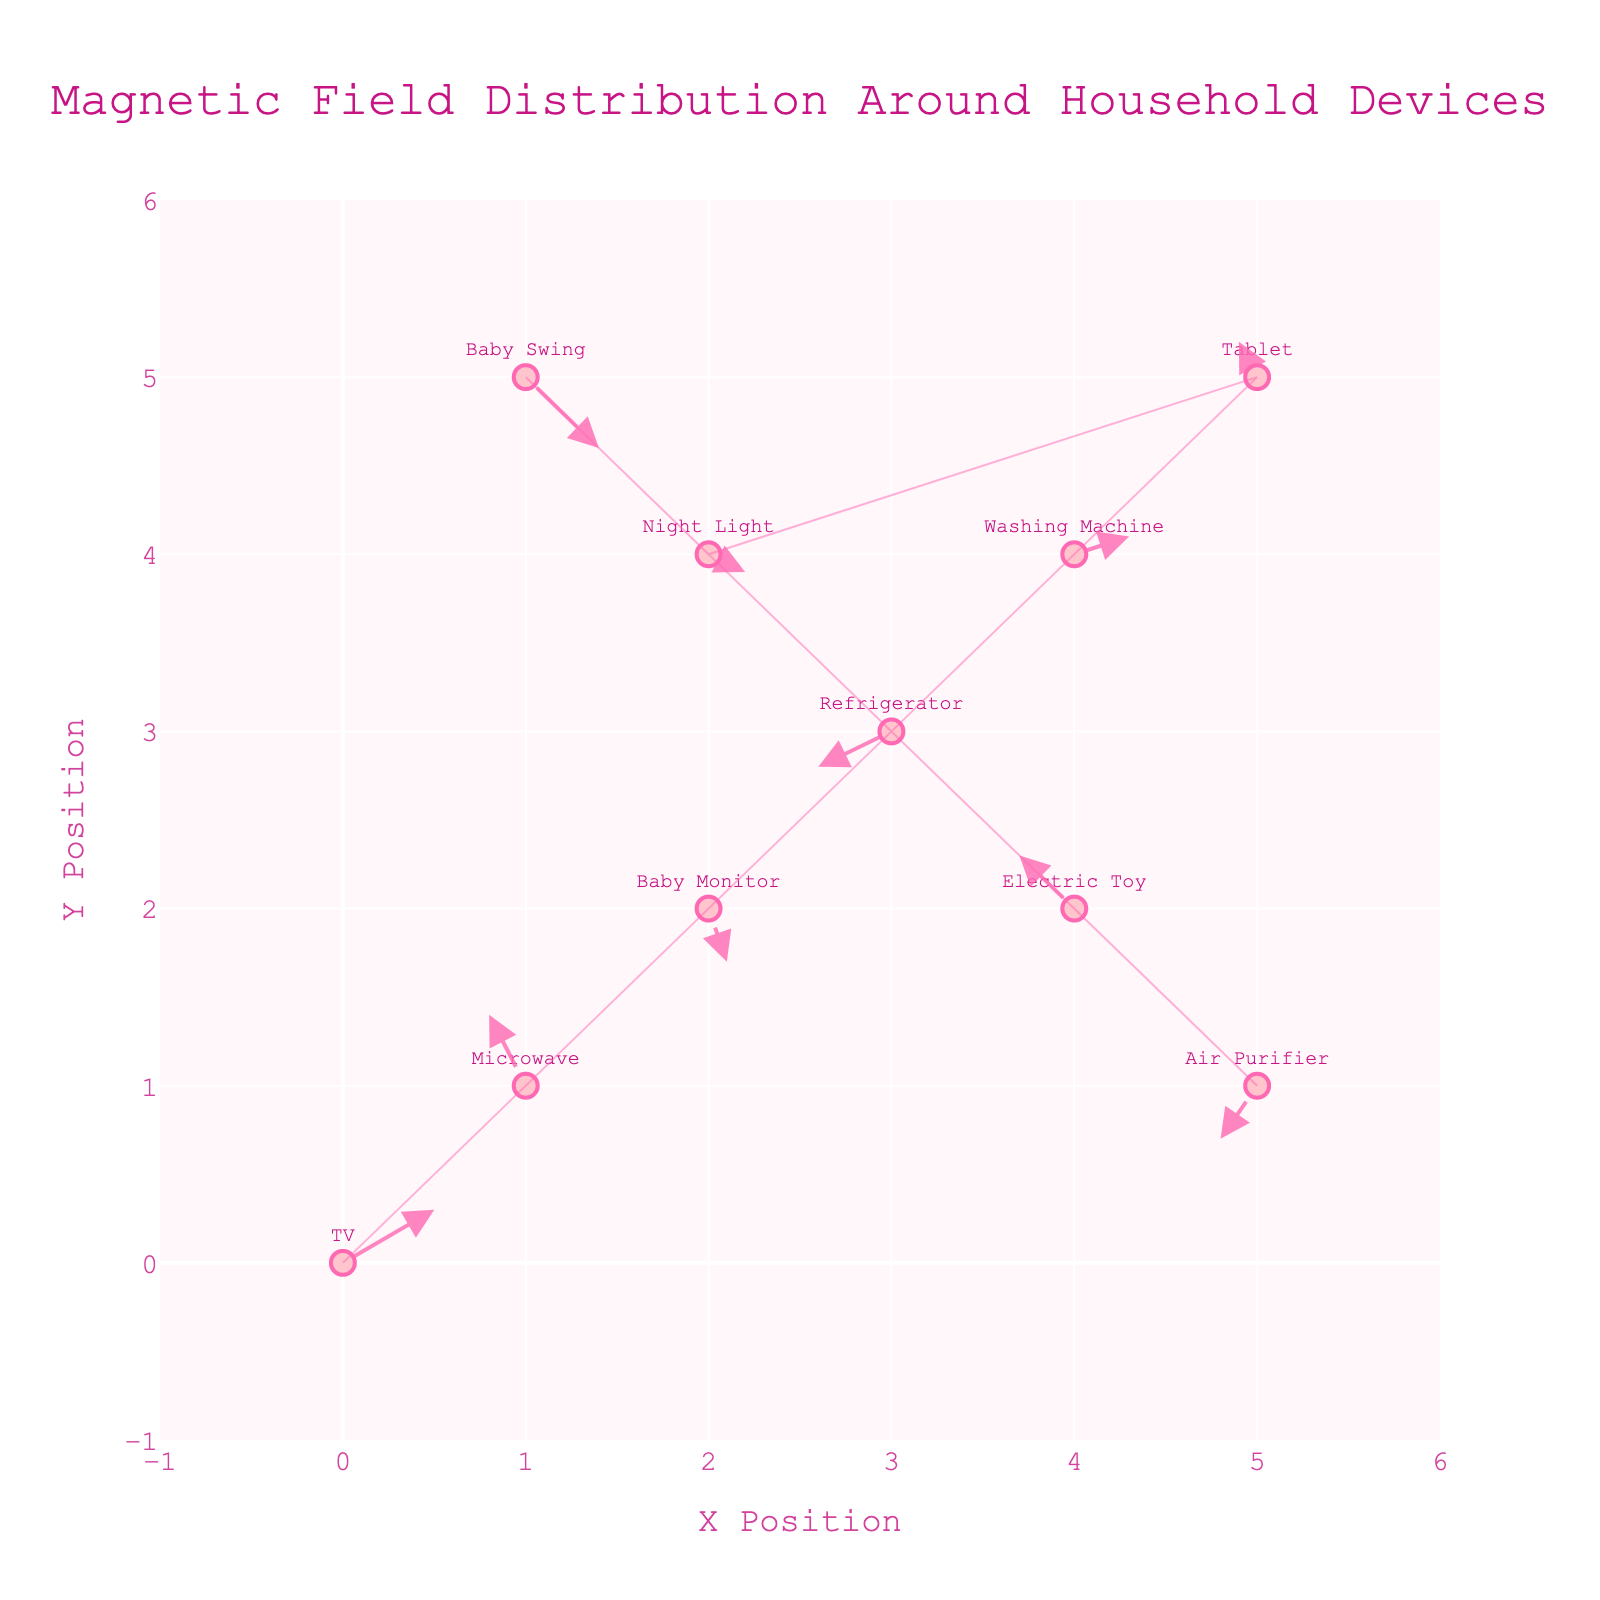What is the title of the plot? The title of the plot is usually located at the top center of the figure. In this case, according to our description, it says "Magnetic Field Distribution Around Household Devices."
Answer: Magnetic Field Distribution Around Household Devices How many electronic devices are shown in the plot? Each device is marked by a label with its name. By counting the unique labels, we find that there are 10 devices.
Answer: 10 Which device is located at the position (5, 5)? To find this, locate the coordinates (5, 5) on the plot and check the label of the device positioned there. It is marked as "Tablet."
Answer: Tablet Which device has the strongest magnetic field in the negative X direction? To identify this, look at the vector lengths and directions pointing leftward (negative X direction). The Refrigerator at (3, 3) has a U value of -0.4, which is the strongest in the negative X direction.
Answer: Refrigerator What is the color of the arrows in the plot? The arrows are colored 'rgba(255, 105, 180, 0.8)', which translates to a shade of pink.
Answer: Pink Which device exerts a magnetic field vector of (0.2, -0.1)? Match the given vector (0.2, -0.1) with the device vectors shown in the plot. The device at (2, 4) labeled "Night Light" has this vector.
Answer: Night Light Compare the magnetic field directions of the TV and the Air Purifier. Are they in the same, opposite, or different directions? The TV at (0, 0) has a vector (0.5, 0.3) directing generally right and upwards, whereas the Air Purifier at (5, 1) has a vector (-0.2, -0.3) directing left and downwards. Their directions are opposite.
Answer: Opposite What is the average magnitude of the magnetic field vectors for the devices located at y=4? To find this, consider the devices at y=4: Night Light at (2, 4) with vector (0.2, -0.1) and Washing Machine at (4, 4) with vector (0.3, 0.1). Calculate the magnitudes: sqrt(0.2^2 + (-0.1)^2) ≈ 0.22 and sqrt(0.3^2 + 0.1^2) ≈ 0.32. Their average is (0.22 + 0.32) / 2 ≈ 0.27.
Answer: 0.27 Which device's magnetic field vector has the smallest magnitude? To identify, calculate the magnitudes of all vectors. The Baby Monitor at (2, 2) has a vector of (0.1, -0.3), with magnitude sqrt(0.1^2 + (-0.3)^2) ≈ 0.32, which is the smallest among all.
Answer: Baby Monitor 